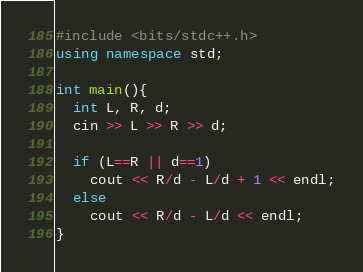<code> <loc_0><loc_0><loc_500><loc_500><_C++_>#include <bits/stdc++.h>
using namespace std;

int main(){
  int L, R, d;
  cin >> L >> R >> d;
  
  if (L==R || d==1)
  	cout << R/d - L/d + 1 << endl;
  else 
    cout << R/d - L/d << endl;
}</code> 